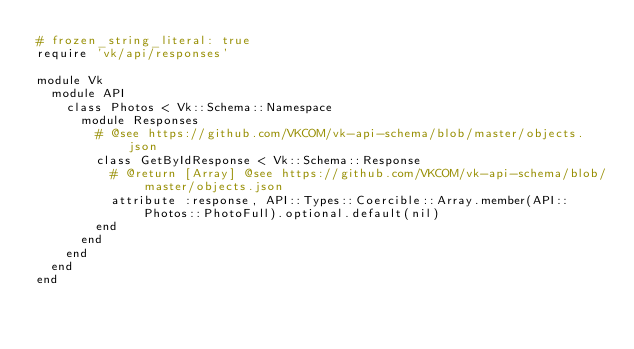<code> <loc_0><loc_0><loc_500><loc_500><_Ruby_># frozen_string_literal: true
require 'vk/api/responses'

module Vk
  module API
    class Photos < Vk::Schema::Namespace
      module Responses
        # @see https://github.com/VKCOM/vk-api-schema/blob/master/objects.json
        class GetByIdResponse < Vk::Schema::Response
          # @return [Array] @see https://github.com/VKCOM/vk-api-schema/blob/master/objects.json
          attribute :response, API::Types::Coercible::Array.member(API::Photos::PhotoFull).optional.default(nil)
        end
      end
    end
  end
end
</code> 